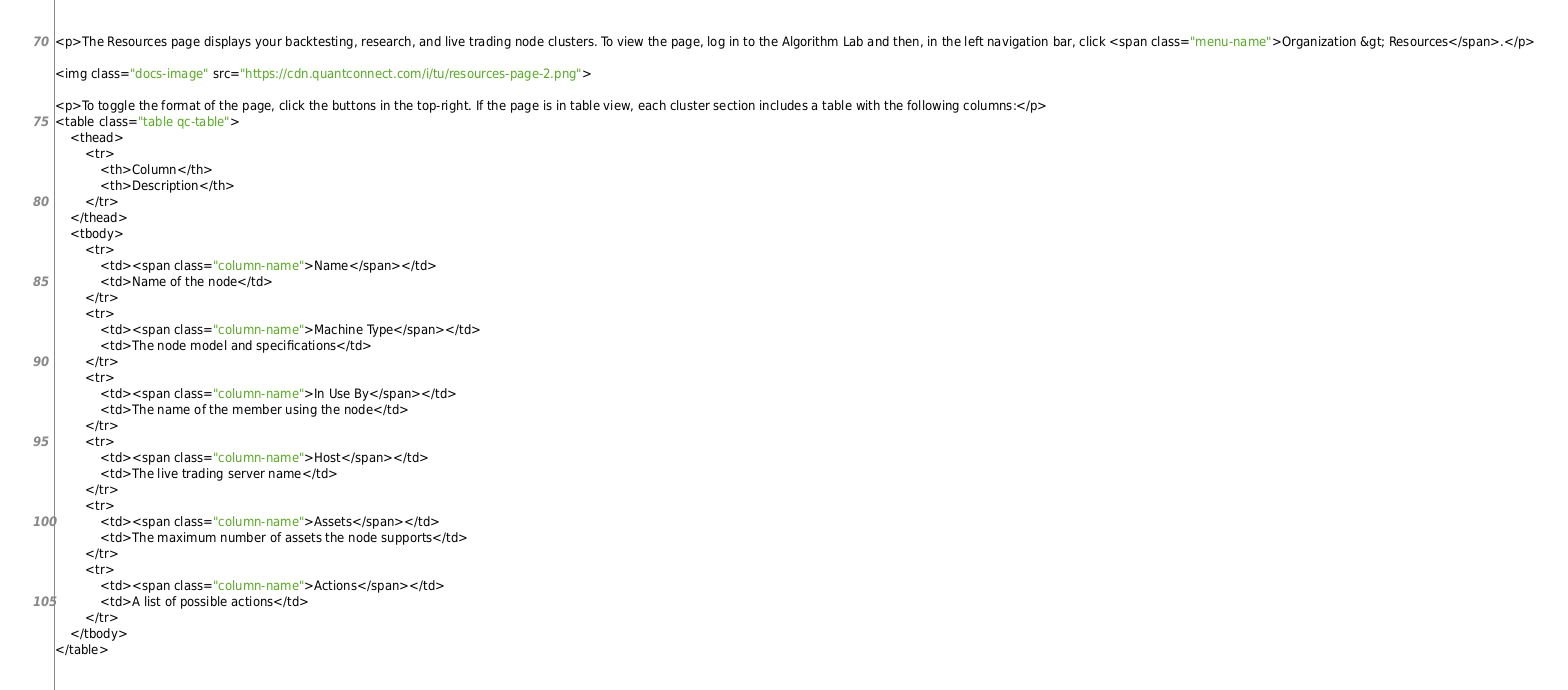Convert code to text. <code><loc_0><loc_0><loc_500><loc_500><_HTML_><p>The Resources page displays your backtesting, research, and live trading node clusters. To view the page, log in to the Algorithm Lab and then, in the left navigation bar, click <span class="menu-name">Organization &gt; Resources</span>.</p>

<img class="docs-image" src="https://cdn.quantconnect.com/i/tu/resources-page-2.png">

<p>To toggle the format of the page, click the buttons in the top-right. If the page is in table view, each cluster section includes a table with the following columns:</p>
<table class="table qc-table">
    <thead>
        <tr>
            <th>Column</th>
            <th>Description</th>
        </tr>
    </thead>
    <tbody>
        <tr>
            <td><span class="column-name">Name</span></td>
            <td>Name of the node</td>
        </tr>
        <tr>
            <td><span class="column-name">Machine Type</span></td>
            <td>The node model and specifications</td>
        </tr>
        <tr>
            <td><span class="column-name">In Use By</span></td>
            <td>The name of the member using the node</td>
        </tr>
        <tr>
            <td><span class="column-name">Host</span></td>
            <td>The live trading server name</td>
        </tr>
        <tr>
            <td><span class="column-name">Assets</span></td>
            <td>The maximum number of assets the node supports</td>
        </tr>
        <tr>
            <td><span class="column-name">Actions</span></td>
            <td>A list of possible actions</td>
        </tr>
    </tbody>
</table></code> 